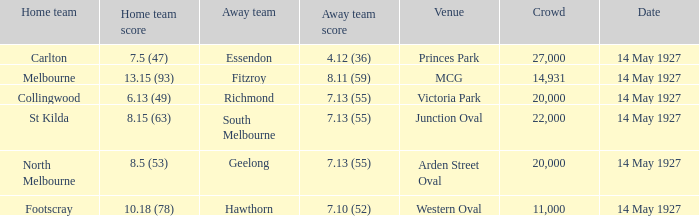What was the home team when the Geelong away team had a score of 7.13 (55)? North Melbourne. 